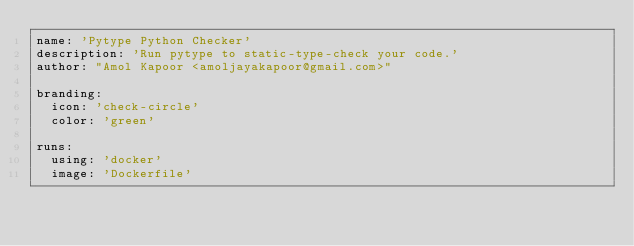Convert code to text. <code><loc_0><loc_0><loc_500><loc_500><_YAML_>name: 'Pytype Python Checker'
description: 'Run pytype to static-type-check your code.'
author: "Amol Kapoor <amoljayakapoor@gmail.com>"

branding:
  icon: 'check-circle'
  color: 'green'

runs:
  using: 'docker'
  image: 'Dockerfile'
</code> 